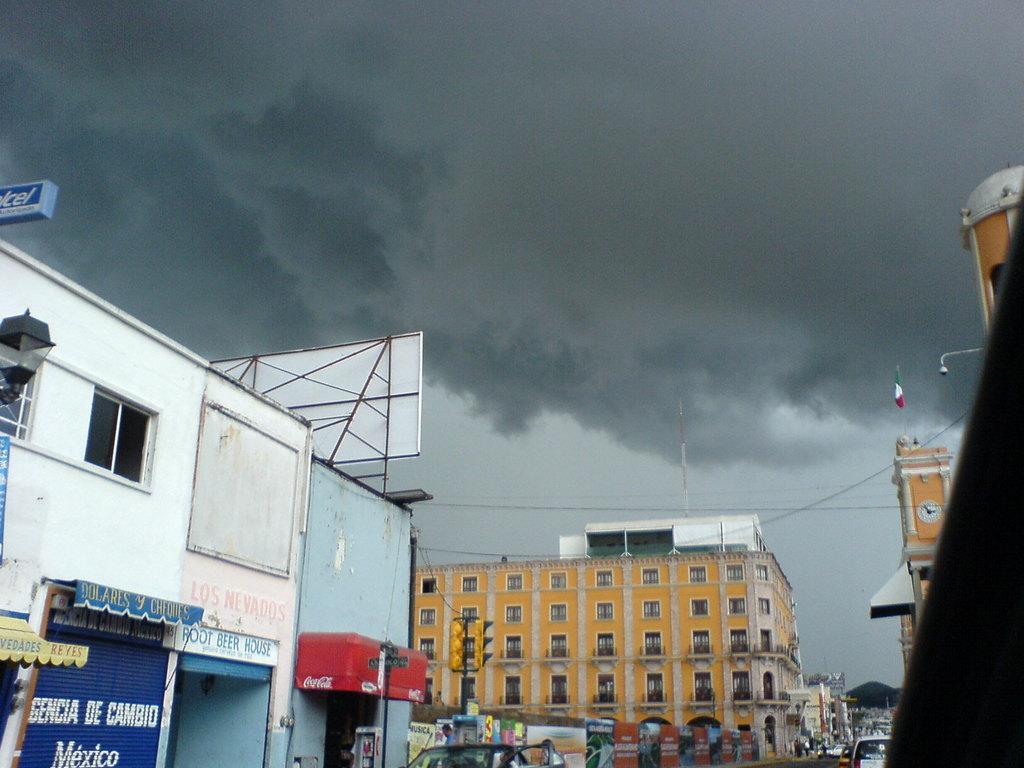How would you summarize this image in a sentence or two? In this image we can see some buildings, wordings, shops and there is a flag on one of the building and top of the image there is cloudy sky. 